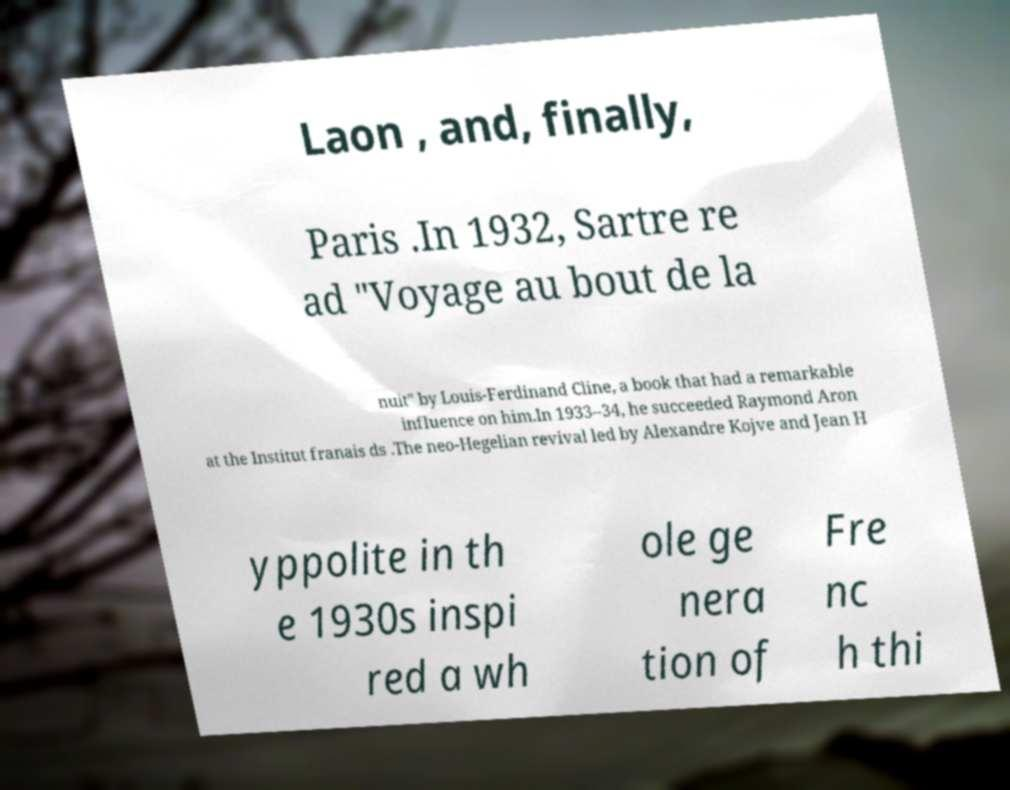I need the written content from this picture converted into text. Can you do that? Laon , and, finally, Paris .In 1932, Sartre re ad "Voyage au bout de la nuit" by Louis-Ferdinand Cline, a book that had a remarkable influence on him.In 1933–34, he succeeded Raymond Aron at the Institut franais ds .The neo-Hegelian revival led by Alexandre Kojve and Jean H yppolite in th e 1930s inspi red a wh ole ge nera tion of Fre nc h thi 